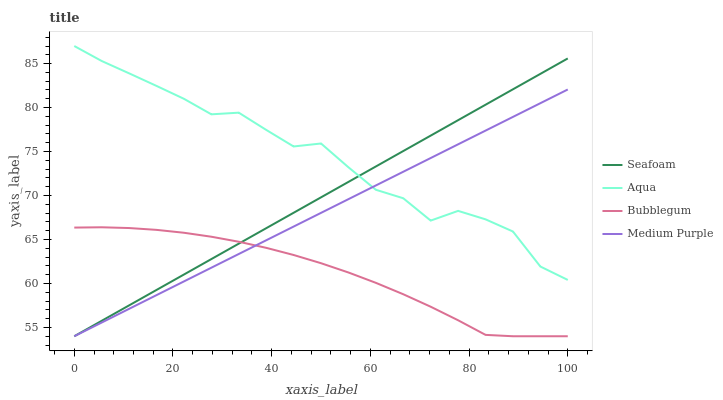Does Bubblegum have the minimum area under the curve?
Answer yes or no. Yes. Does Aqua have the maximum area under the curve?
Answer yes or no. Yes. Does Seafoam have the minimum area under the curve?
Answer yes or no. No. Does Seafoam have the maximum area under the curve?
Answer yes or no. No. Is Medium Purple the smoothest?
Answer yes or no. Yes. Is Aqua the roughest?
Answer yes or no. Yes. Is Seafoam the smoothest?
Answer yes or no. No. Is Seafoam the roughest?
Answer yes or no. No. Does Aqua have the lowest value?
Answer yes or no. No. Does Aqua have the highest value?
Answer yes or no. Yes. Does Seafoam have the highest value?
Answer yes or no. No. Is Bubblegum less than Aqua?
Answer yes or no. Yes. Is Aqua greater than Bubblegum?
Answer yes or no. Yes. Does Aqua intersect Medium Purple?
Answer yes or no. Yes. Is Aqua less than Medium Purple?
Answer yes or no. No. Is Aqua greater than Medium Purple?
Answer yes or no. No. Does Bubblegum intersect Aqua?
Answer yes or no. No. 